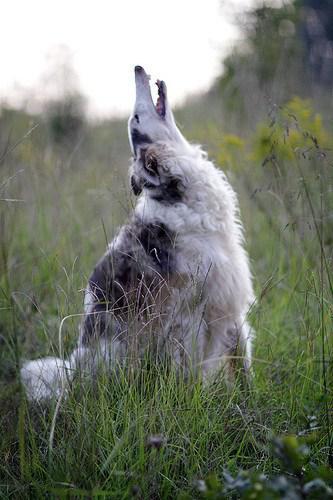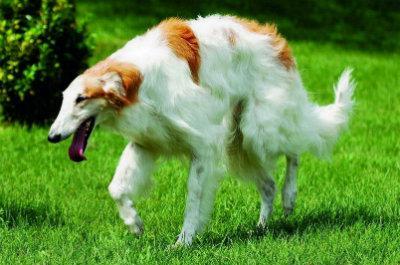The first image is the image on the left, the second image is the image on the right. Considering the images on both sides, is "There are two dogs" valid? Answer yes or no. Yes. The first image is the image on the left, the second image is the image on the right. Analyze the images presented: Is the assertion "There are two dogs in total." valid? Answer yes or no. Yes. The first image is the image on the left, the second image is the image on the right. Examine the images to the left and right. Is the description "One image includes at least twice as many hounds in the foreground as the other image." accurate? Answer yes or no. No. 